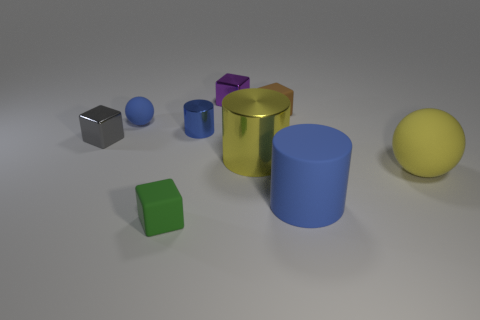How many things are green matte objects or small green matte balls?
Give a very brief answer. 1. Are there any large yellow metallic objects on the right side of the brown cube?
Your answer should be very brief. No. Is there another small green object that has the same material as the tiny green thing?
Offer a terse response. No. What size is the rubber sphere that is the same color as the tiny metal cylinder?
Keep it short and to the point. Small. What number of blocks are tiny purple objects or yellow matte things?
Make the answer very short. 1. Are there more big yellow matte things that are behind the tiny gray shiny thing than yellow shiny cylinders that are behind the small purple shiny cube?
Your answer should be very brief. No. What number of objects have the same color as the tiny matte ball?
Offer a terse response. 2. There is a gray cube that is made of the same material as the yellow cylinder; what is its size?
Keep it short and to the point. Small. What number of objects are either small matte things that are on the left side of the green rubber object or small yellow objects?
Give a very brief answer. 1. Is the color of the metal thing behind the tiny blue cylinder the same as the small matte sphere?
Make the answer very short. No. 